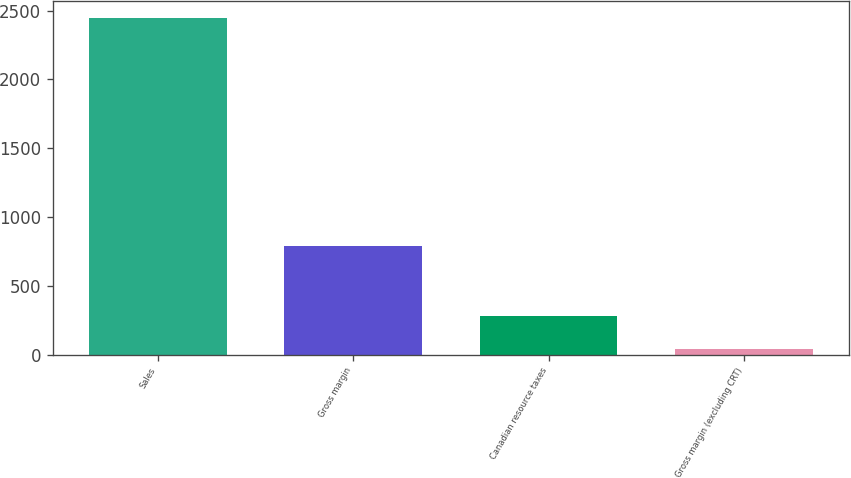<chart> <loc_0><loc_0><loc_500><loc_500><bar_chart><fcel>Sales<fcel>Gross margin<fcel>Canadian resource taxes<fcel>Gross margin (excluding CRT)<nl><fcel>2447<fcel>788.3<fcel>282.77<fcel>42.3<nl></chart> 